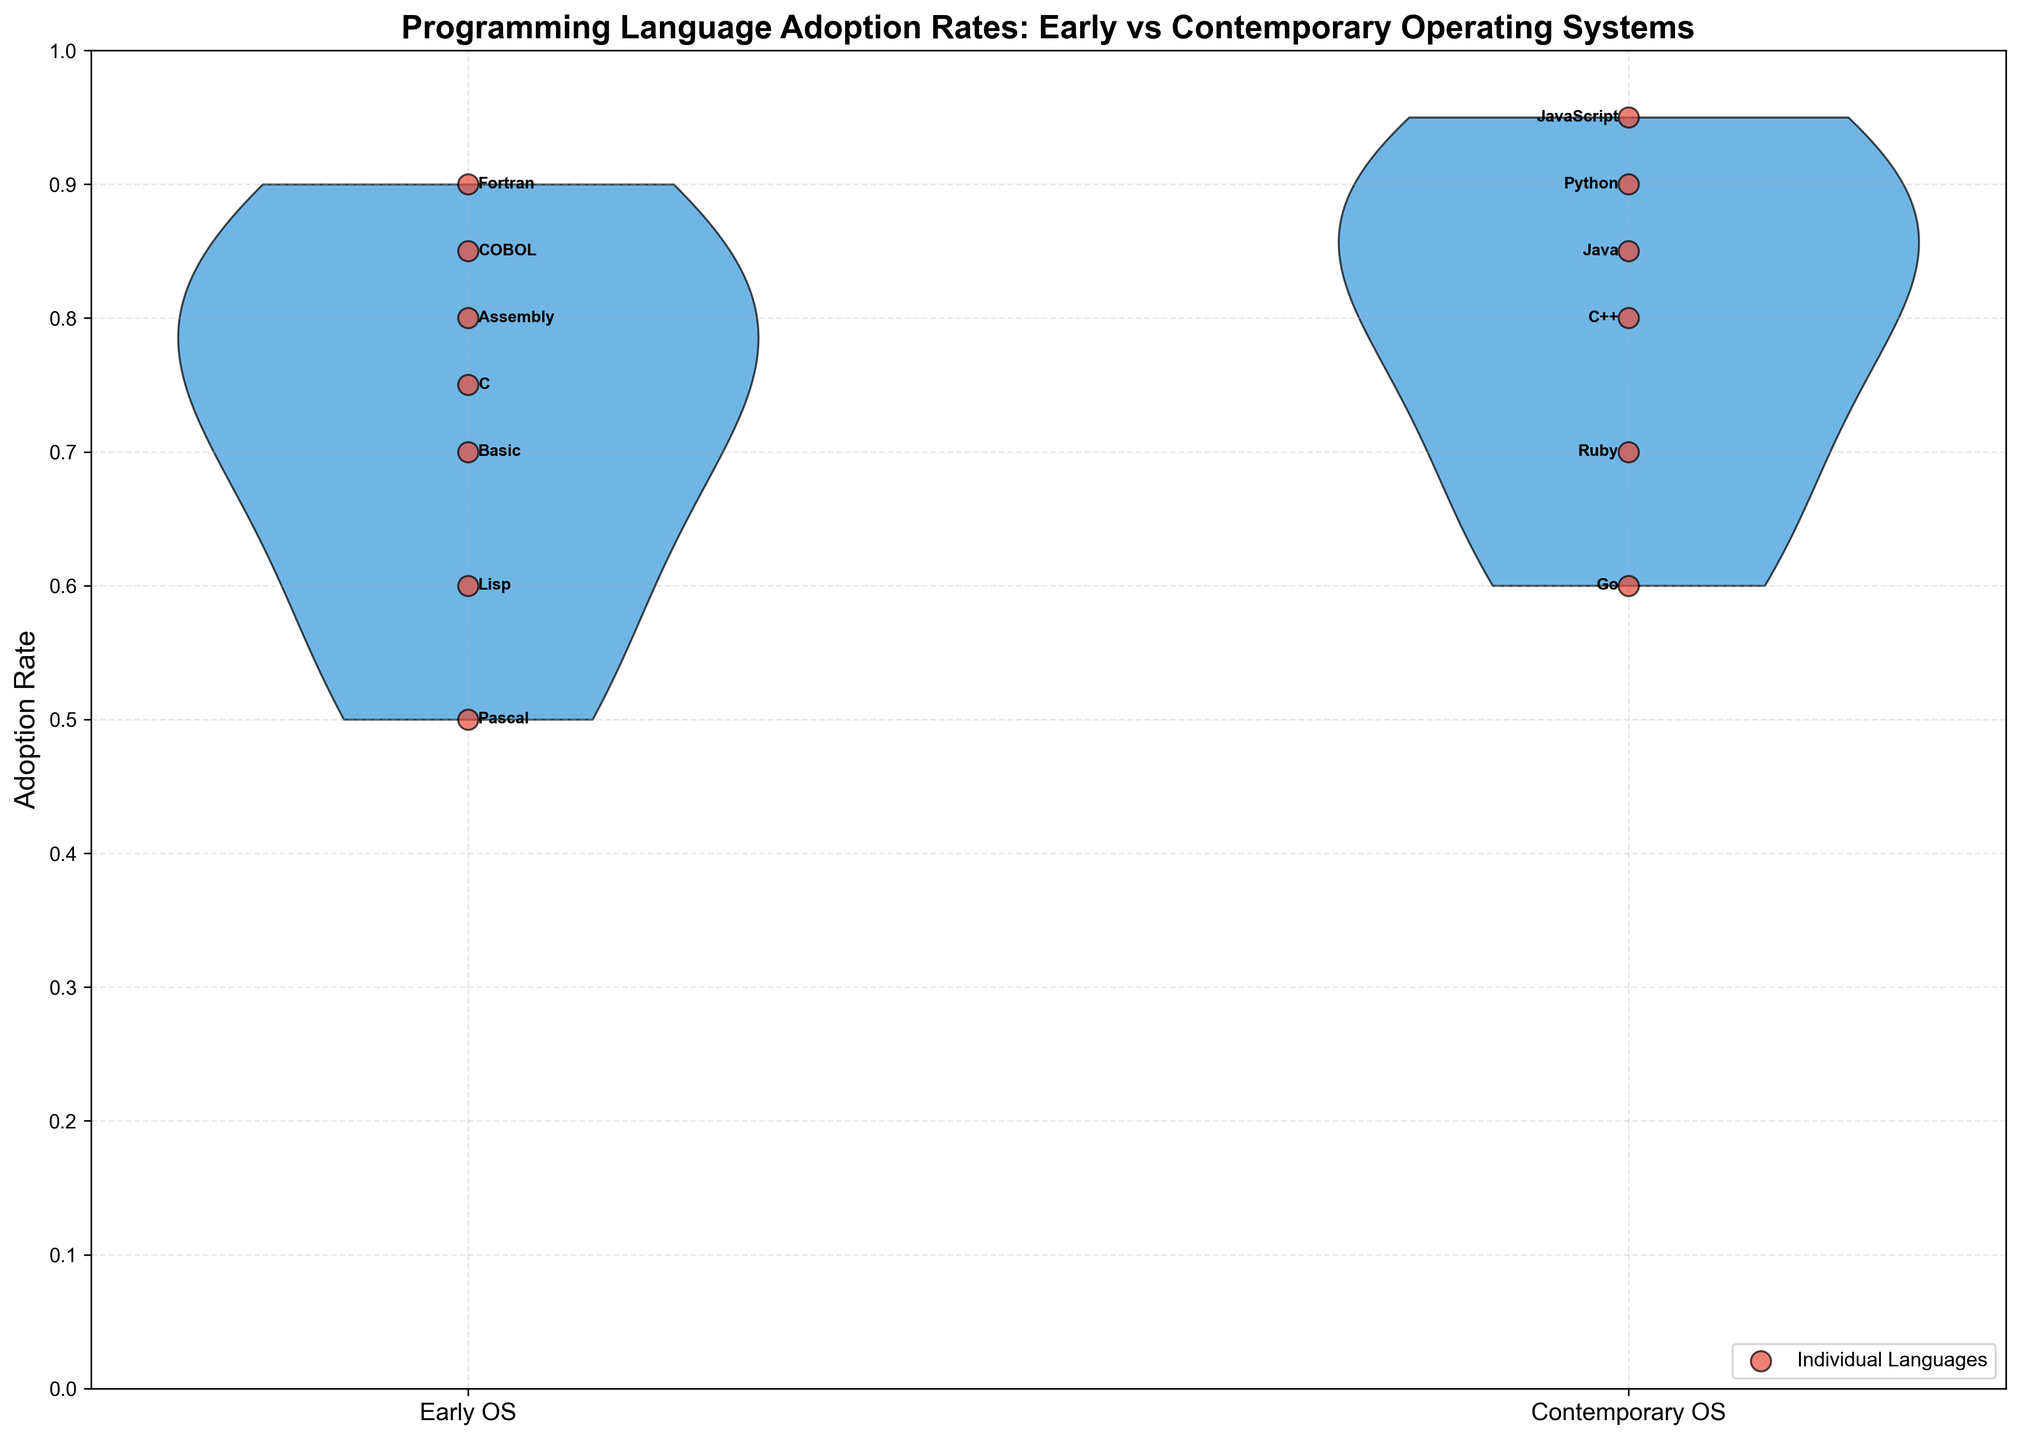What is the title of the plot? The title is a text element typically found at the top of the plot. It describes what the plot is about. In this case, the title indicates the focus on the adoption rates of programming languages during different eras of operating systems.
Answer: Programming Language Adoption Rates: Early vs Contemporary Operating Systems How many operating systems are represented in each era? By referring to each violin plot, we can see how many data points are plotted for both 'Early' and 'Contemporary' eras. Each data point corresponds to a programming language associated with a specific operating system. We count the scattered points to determine the number of represented operating systems.
Answer: 7 (Early), 6 (Contemporary) Which era has the highest recorded adoption rate and what programming language does it correspond to? In the plot, the highest adoption rate for each era is shown by the individual scatter points. The violin distribution also helps indicate the highest value, but the scatter points make it clearer. For the 'Contemporary' era, Python has the highest adoption rate.
Answer: Contemporary, Python Which era shows a wider range of adoption rates? The range of a dataset is determined by the difference between the highest and lowest values. A violin plot visualizes this spread. For each era, observe the vertical extent of the violin plot to see which one covers a larger range. The larger the range, the wider the distribution.
Answer: Early What is the average adoption rate of programming languages in the 'Contemporary' era? To find the average adoption rate, sum all the adoption rates provided for the 'Contemporary' era and then divide by the number of programming languages in that era. i.e., (0.8 + 0.85 + 0.9 + 0.95 + 0.7 + 0.6) / 6 = 4.8 / 6 = 0.8.
Answer: 0.8 How do the median adoption rates for the 'Early' and 'Contemporary' eras compare? The median value is found by sorting the values and then picking the middle one (or averaging the two middle values if there's an even number). For the 'Early' era: sort (0.8, 0.9, 0.85, 0.6, 0.75, 0.5, 0.7) -> 0.5, 0.6, 0.7, 0.75, 0.8, 0.85, 0.9; median = 0.75. For the 'Contemporary' era: sort (0.8, 0.85, 0.9, 0.95, 0.7, 0.6) -> 0.6, 0.7, 0.8, 0.85, 0.9, 0.95; median = (0.8+0.85)/2 = 0.825.
Answer: 0.75 (Early), 0.825 (Contemporary) Which programming language has the lowest adoption rate in the 'Early' era, and how does it compare to the lowest in the 'Contemporary' era? Identify the lowest scatter point on the violin plot for each era. Annotated labels help in identifying the programming languages. The lowest rates would be 0.5 for Pascal (Early) and 0.6 for Go (Contemporary). Comparison involves directly noting which is lower and by how much.
Answer: Pascal (0.5) in Early is lower compared to Go (0.6) in Contemporary Are there any programming languages that have the same adoption rate in both eras? Scan the violin plots and scatter points to identify if any rates overlap between the two eras. Cross-check annotated labels to note any common rates. In this case, 0.8 is observed in both eras but for different languages.
Answer: Yes, 0.8 (C in Early and C++ in Contemporary) What is the interquartile range (IQR) of the 'Early' era's adoption rates? The IQR is calculated as the difference between the third quartile (Q3) and the first quartile (Q1). For 'Early' era: sorted values are 0.5, 0.6, 0.7, 0.75, 0.8, 0.85, 0.9. Q1 (25th percentile) is 0.65 and Q3 (75th percentile) is 0.825. So, IQR = 0.825 - 0.65 = 0.175.
Answer: 0.175 Which era shows a higher variability in the adoption rates of programming languages, and how is it determined? Variability is typically measured by spread or range. In this plot, evaluating the vertical span of each violin plot indicates which has more variability. The Early era's plot has a wider spread compared to the Contemporary era.
Answer: Early, by visual inspection of wider spread 